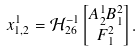<formula> <loc_0><loc_0><loc_500><loc_500>x _ { 1 , 2 } ^ { 1 } & = \mathcal { H } _ { 2 6 } ^ { - 1 } \begin{bmatrix} A _ { 2 } ^ { 1 } B _ { 1 } ^ { 2 } \\ F _ { 1 } ^ { 2 } \end{bmatrix} .</formula> 